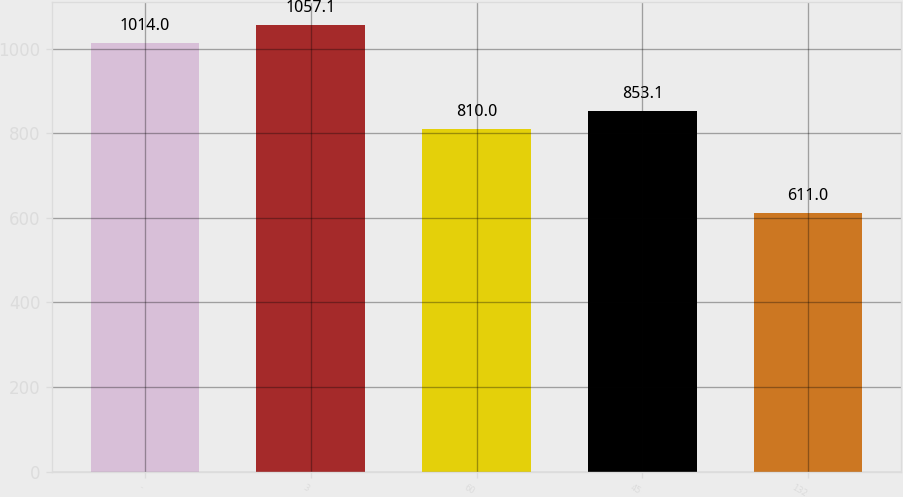Convert chart to OTSL. <chart><loc_0><loc_0><loc_500><loc_500><bar_chart><fcel>-<fcel>3<fcel>60<fcel>45<fcel>132<nl><fcel>1014<fcel>1057.1<fcel>810<fcel>853.1<fcel>611<nl></chart> 